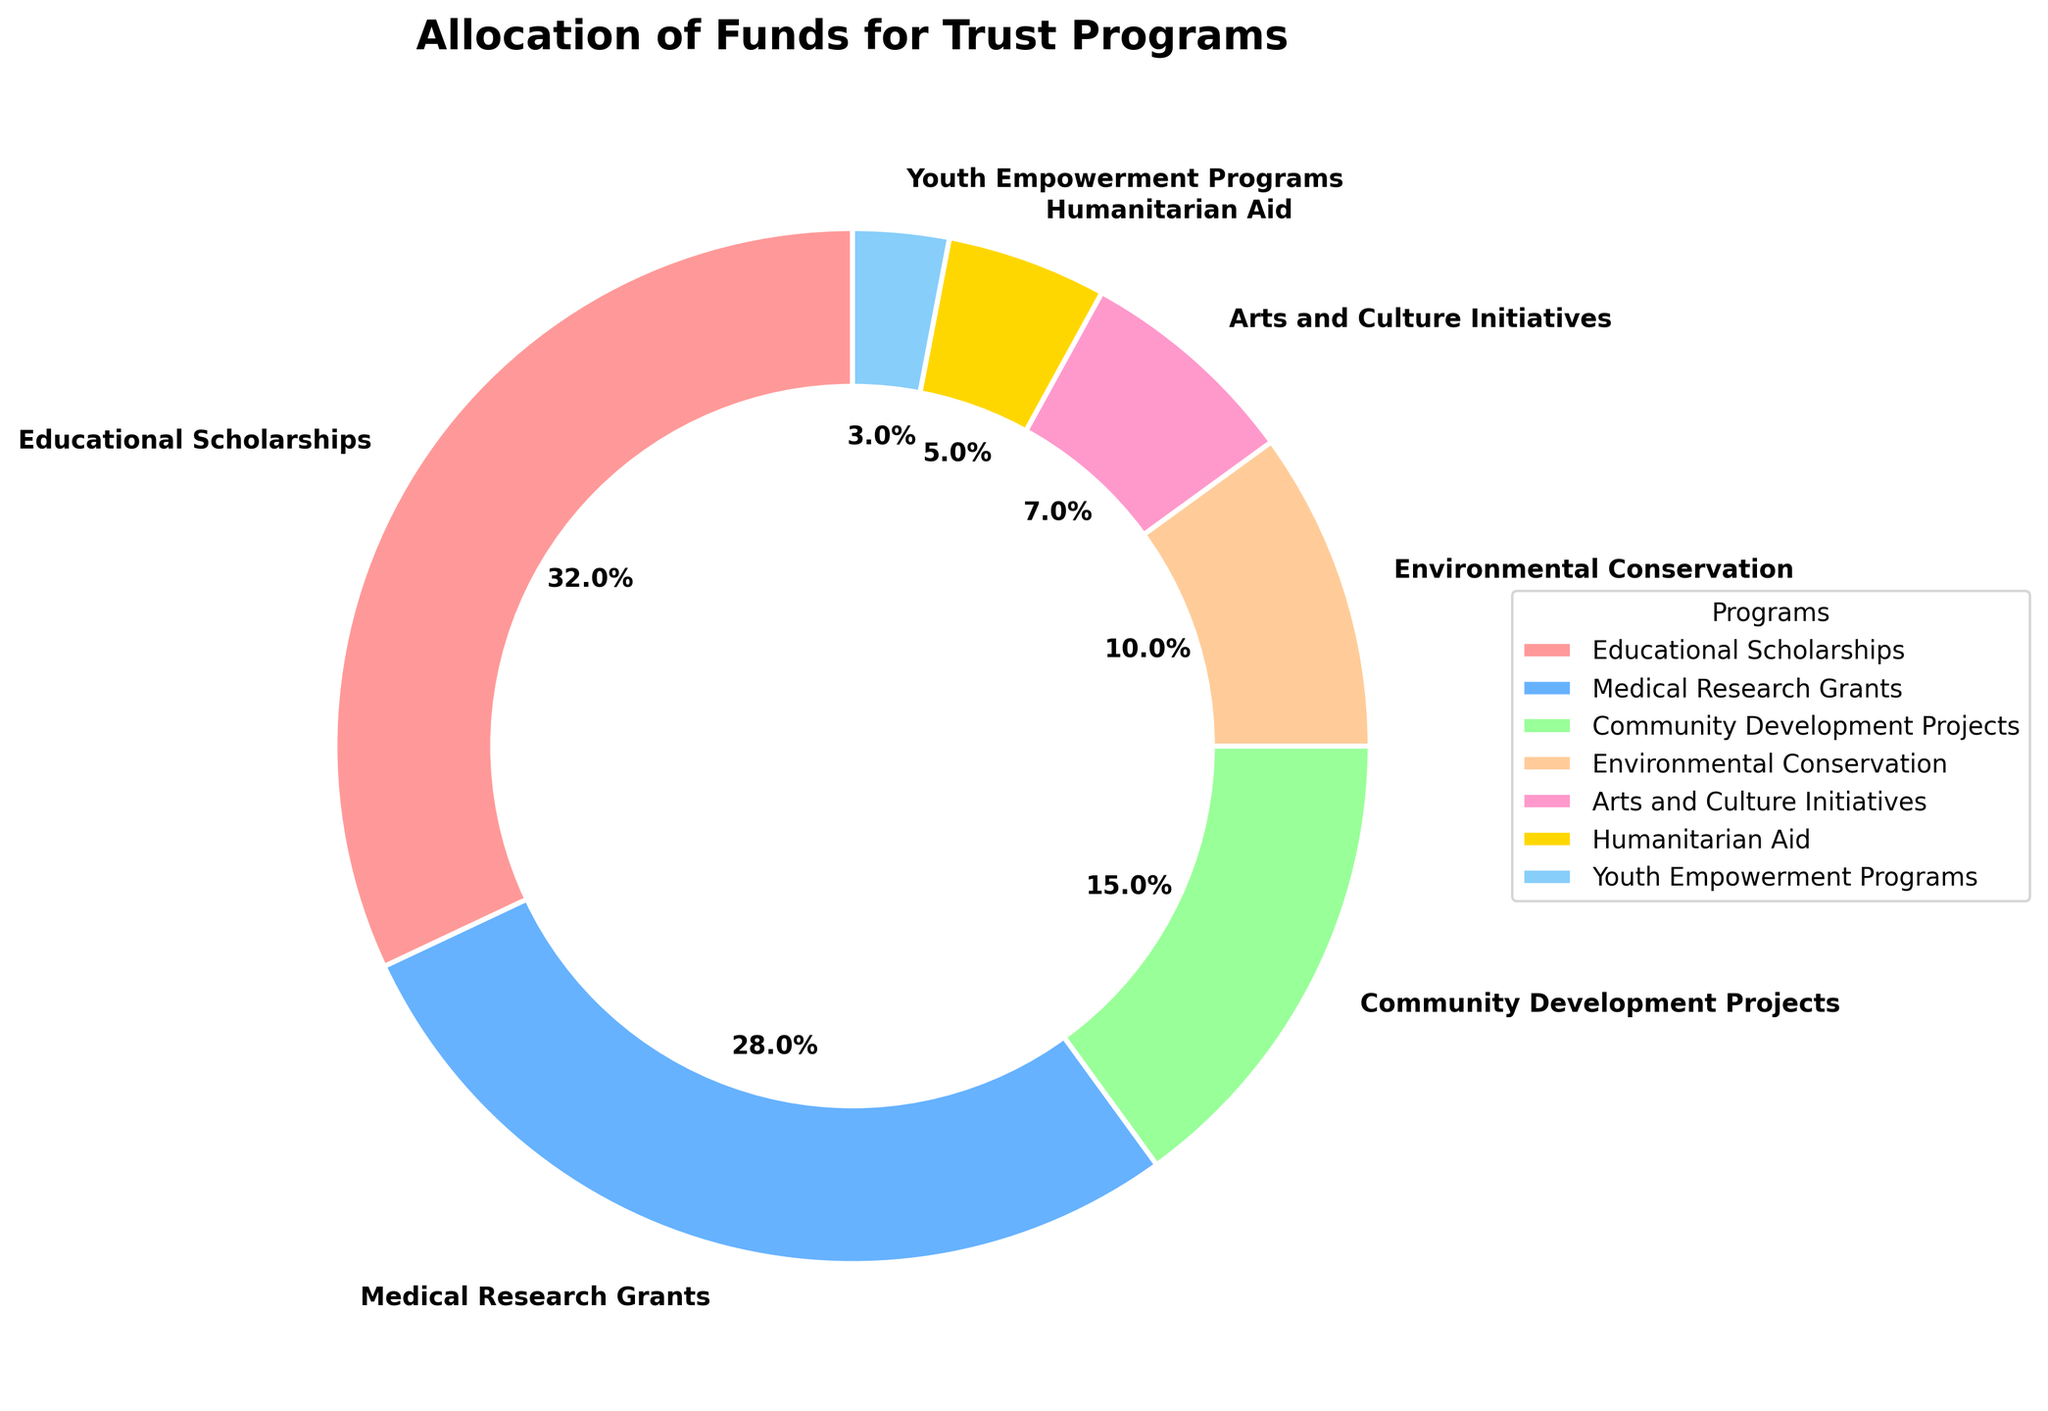What's the largest program by fund allocation? The figure shows that the Educational Scholarships segment is the largest, occupying the most significant portion of the pie chart.
Answer: Educational Scholarships Which two programs combined have the highest fund allocation? The two largest segments in the pie chart are Educational Scholarships (32%) and Medical Research Grants (28%). Combining them, they account for (32 + 28) = 60% of the total funds.
Answer: Educational Scholarships and Medical Research Grants What is the difference in fund allocation between Community Development Projects and Environmental Conservation? Community Development Projects are allocated 15% and Environmental Conservation 10%. The difference is (15 - 10) = 5%.
Answer: 5% Which program has the smallest allocation, and what percentage is it? The Youth Empowerment Programs segment is the smallest in the pie chart, with 3% allocation.
Answer: Youth Empowerment Programs, 3% Among the programs, which two have equal or approximately equal allocations? None of the segments in the pie chart have equal allocations. However, Community Development Projects and Environmental Conservation are somewhat close at 15% and 10%, respectively.
Answer: None If the trust decides to increase the Arts and Culture Initiatives allocation by 3%, which program would it surpass in terms of percentage? Currently, Arts and Culture Initiatives have 7%. Increasing by 3% totals 10%, which would make it equal to Environmental Conservation (10%) but still lower than Community Development Projects (15%).
Answer: None (equal to Environmental Conservation) What proportion of the funds is allocated to Humanitarian Aid and Youth Empowerment Programs combined? Humanitarian Aid has 5%, and Youth Empowerment Programs have 3%. Combined, they account for (5 + 3) = 8% of the total funds.
Answer: 8% How much more percentage is allocated to Medical Research Grants compared to Arts and Culture Initiatives? Medical Research Grants have 28% allocation, and Arts and Culture Initiatives have 7%. The difference is (28 - 7) = 21%.
Answer: 21% What color represents the program with the second-highest allocation, and what is the percentage of this allocation? The second-highest allocation is Medical Research Grants at 28%, represented in the pie chart by a blue color.
Answer: Blue, 28% What is the sum of allocations for Environment Conservation, Arts and Culture Initiatives, and Humanitarian Aid combined? Environmental Conservation is allocated 10%, Arts and Culture Initiatives 7%, and Humanitarian Aid 5%. The combined total is (10 + 7 + 5) = 22%.
Answer: 22% 